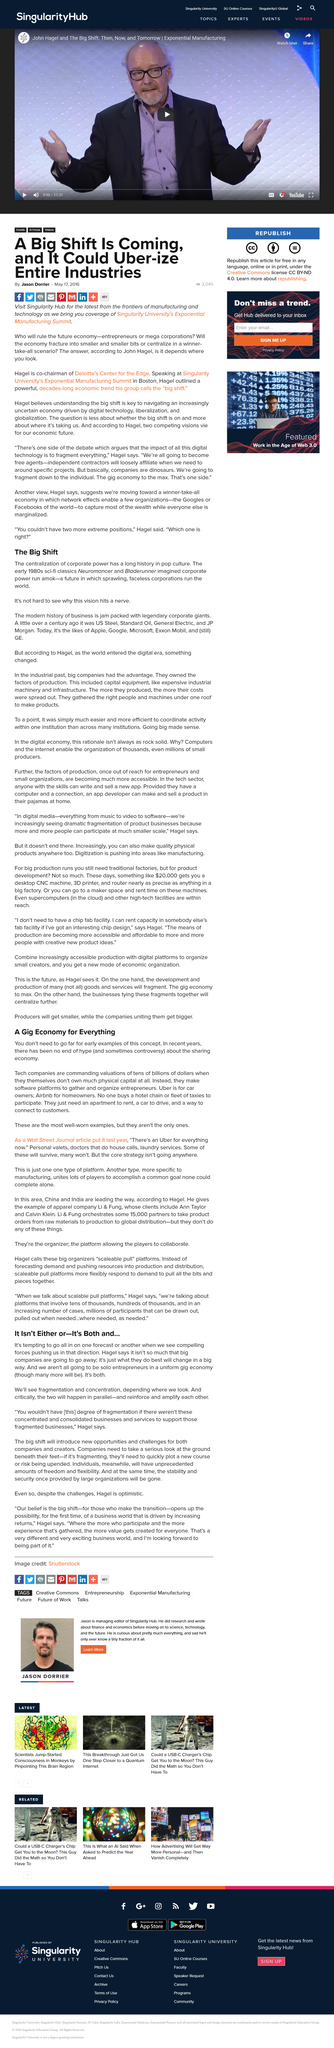Highlight a few significant elements in this photo. In the 1980s, the vision of the future portrayed in movies was one where massive corporations exerted total control over the world. The phrase 'hits a nerve' means that it is a sensitive issue, as it evokes a strong and emotional response from the listener or reader. Two movies, Blade Runner and Neuromancer, are mentioned. Deloitte's Center for the Edge is led by a co-chairman named John Hagel. Examples of tech companies creating software platforms and organizing entrepreneurs, such as Uber and Airbnb, are often cited in discussions of entrepreneurship and technology. 